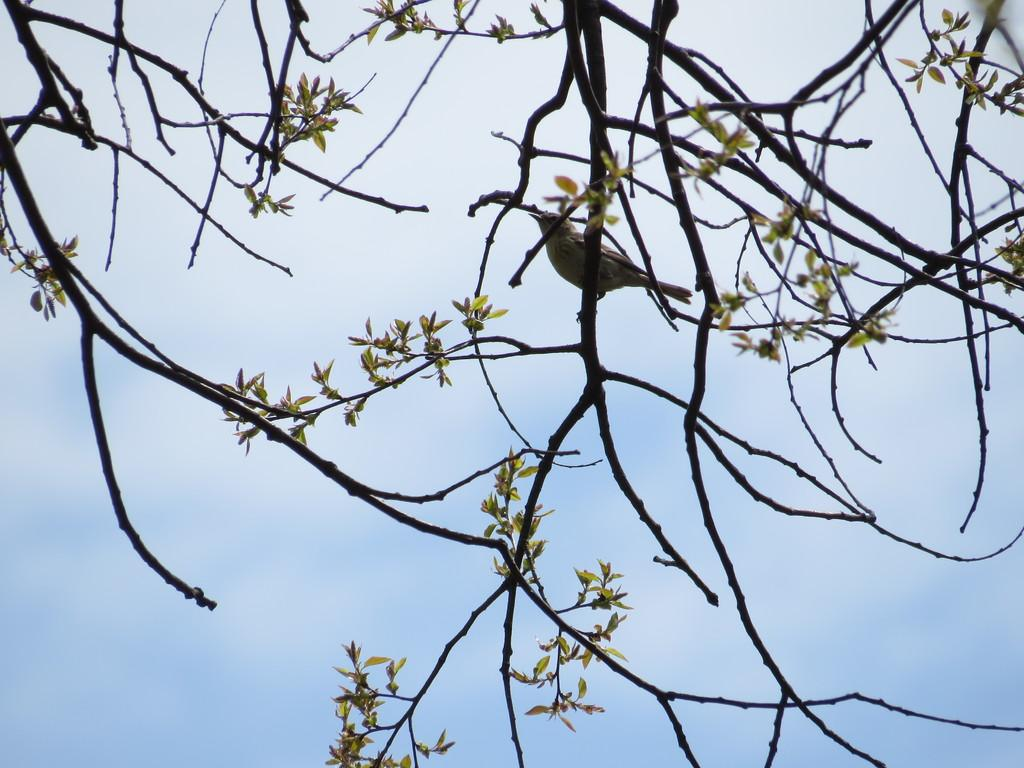What type of animal can be seen in the image? There is a bird in the image. Where is the bird located in the image? The bird is standing on a tree stem. What can be seen in the background of the image? There are tree stems, leaves, and the sky visible in the background of the image. What type of stew is the bird eating in the image? There is no stew present in the image; the bird is standing on a tree stem. Can you see any indication of the bird's throat in the image? The image does not show the bird's throat; it only shows the bird standing on a tree stem. 